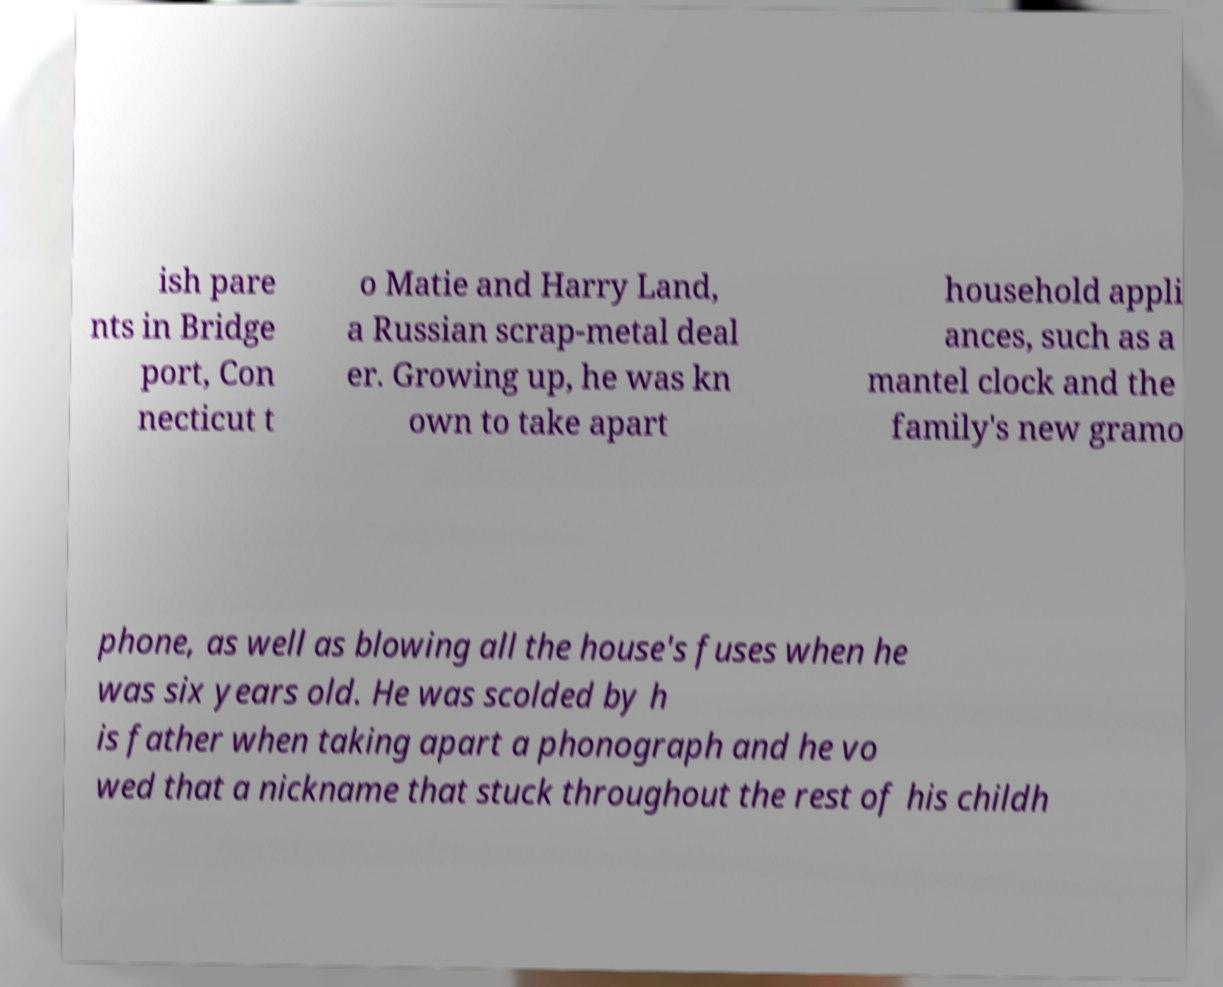I need the written content from this picture converted into text. Can you do that? ish pare nts in Bridge port, Con necticut t o Matie and Harry Land, a Russian scrap-metal deal er. Growing up, he was kn own to take apart household appli ances, such as a mantel clock and the family's new gramo phone, as well as blowing all the house's fuses when he was six years old. He was scolded by h is father when taking apart a phonograph and he vo wed that a nickname that stuck throughout the rest of his childh 